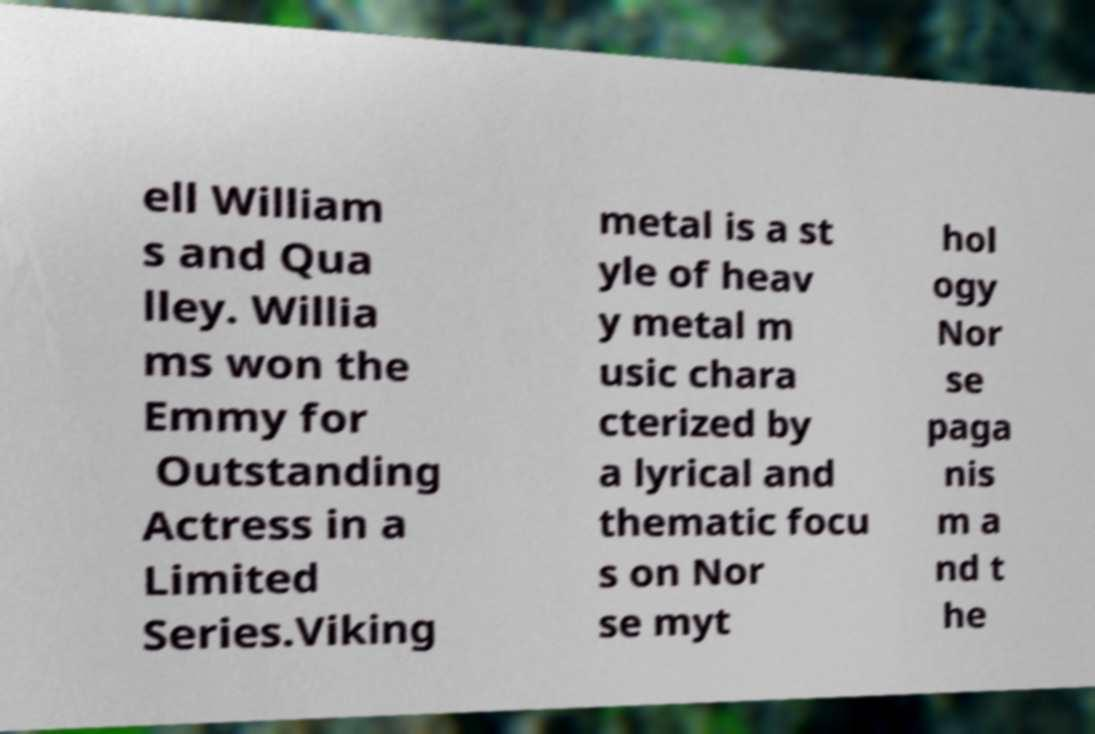For documentation purposes, I need the text within this image transcribed. Could you provide that? ell William s and Qua lley. Willia ms won the Emmy for Outstanding Actress in a Limited Series.Viking metal is a st yle of heav y metal m usic chara cterized by a lyrical and thematic focu s on Nor se myt hol ogy Nor se paga nis m a nd t he 